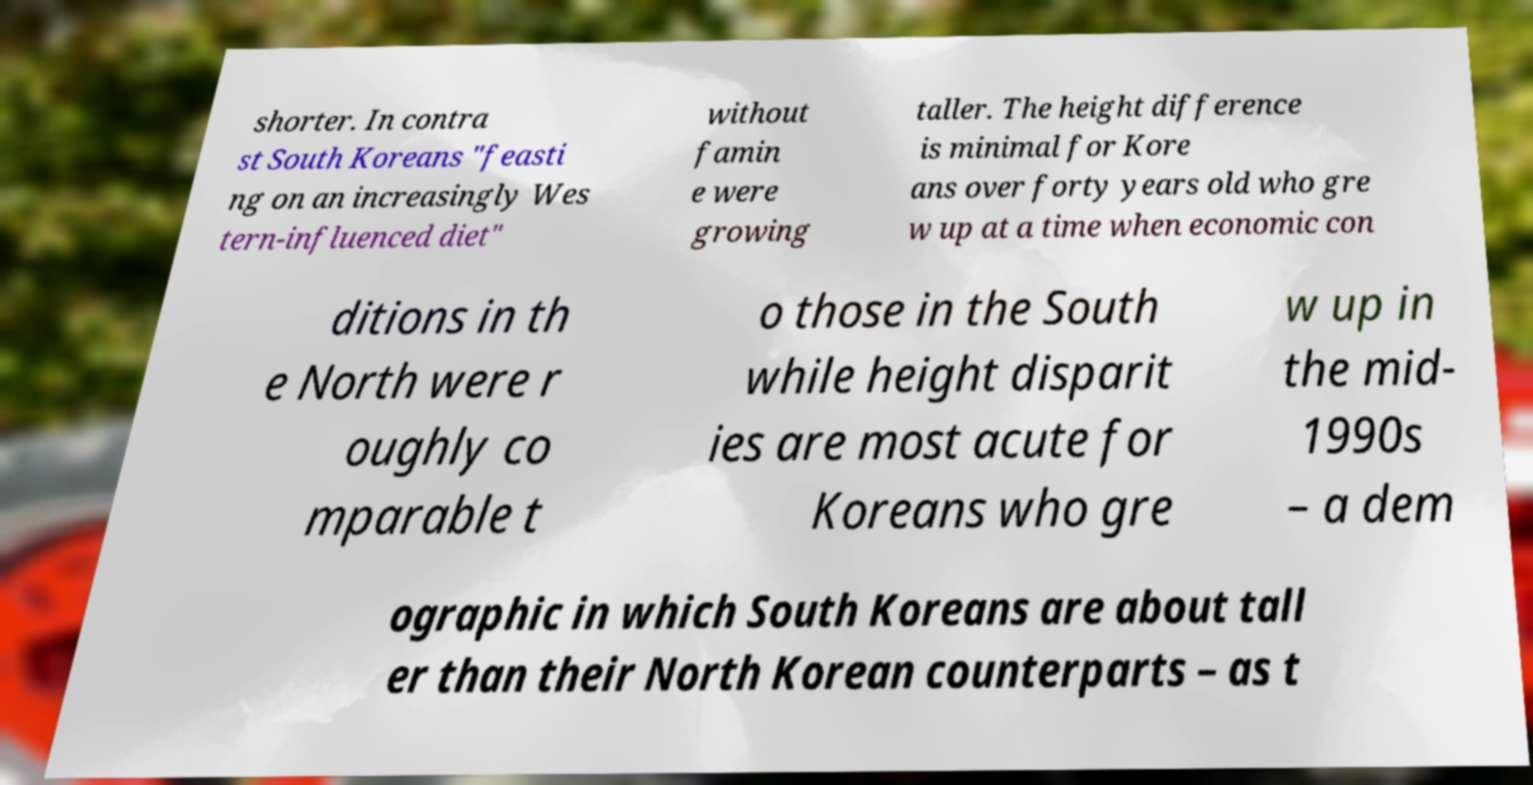Could you extract and type out the text from this image? shorter. In contra st South Koreans "feasti ng on an increasingly Wes tern-influenced diet" without famin e were growing taller. The height difference is minimal for Kore ans over forty years old who gre w up at a time when economic con ditions in th e North were r oughly co mparable t o those in the South while height disparit ies are most acute for Koreans who gre w up in the mid- 1990s – a dem ographic in which South Koreans are about tall er than their North Korean counterparts – as t 